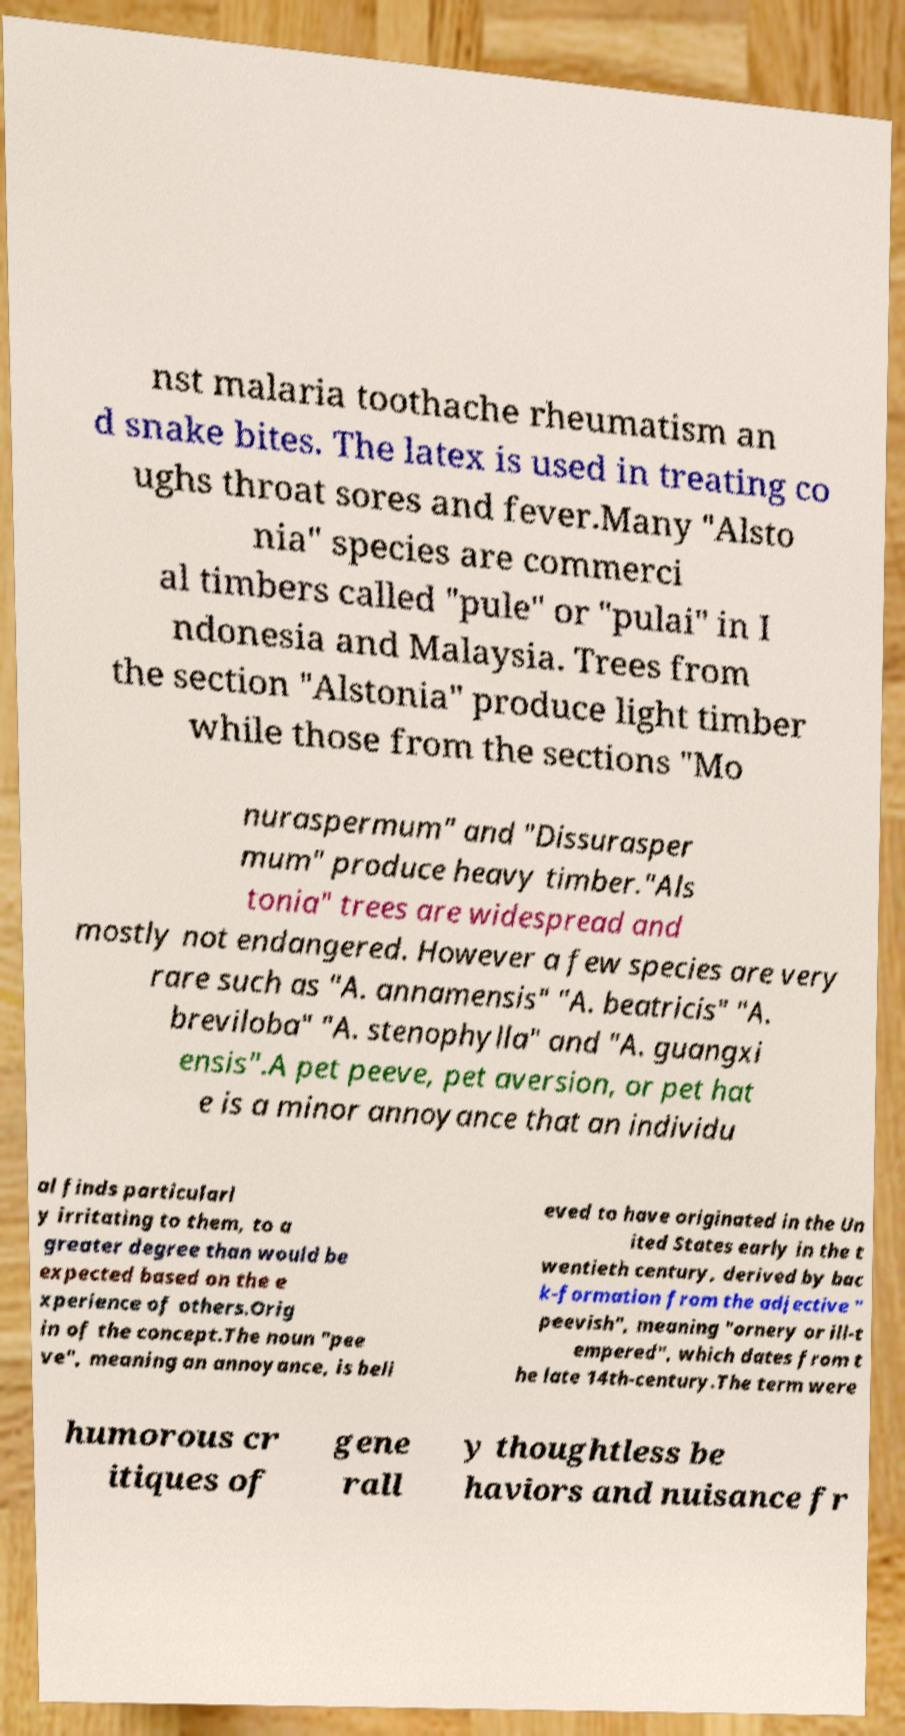Please read and relay the text visible in this image. What does it say? nst malaria toothache rheumatism an d snake bites. The latex is used in treating co ughs throat sores and fever.Many "Alsto nia" species are commerci al timbers called "pule" or "pulai" in I ndonesia and Malaysia. Trees from the section "Alstonia" produce light timber while those from the sections "Mo nuraspermum" and "Dissurasper mum" produce heavy timber."Als tonia" trees are widespread and mostly not endangered. However a few species are very rare such as "A. annamensis" "A. beatricis" "A. breviloba" "A. stenophylla" and "A. guangxi ensis".A pet peeve, pet aversion, or pet hat e is a minor annoyance that an individu al finds particularl y irritating to them, to a greater degree than would be expected based on the e xperience of others.Orig in of the concept.The noun "pee ve", meaning an annoyance, is beli eved to have originated in the Un ited States early in the t wentieth century, derived by bac k-formation from the adjective " peevish", meaning "ornery or ill-t empered", which dates from t he late 14th-century.The term were humorous cr itiques of gene rall y thoughtless be haviors and nuisance fr 